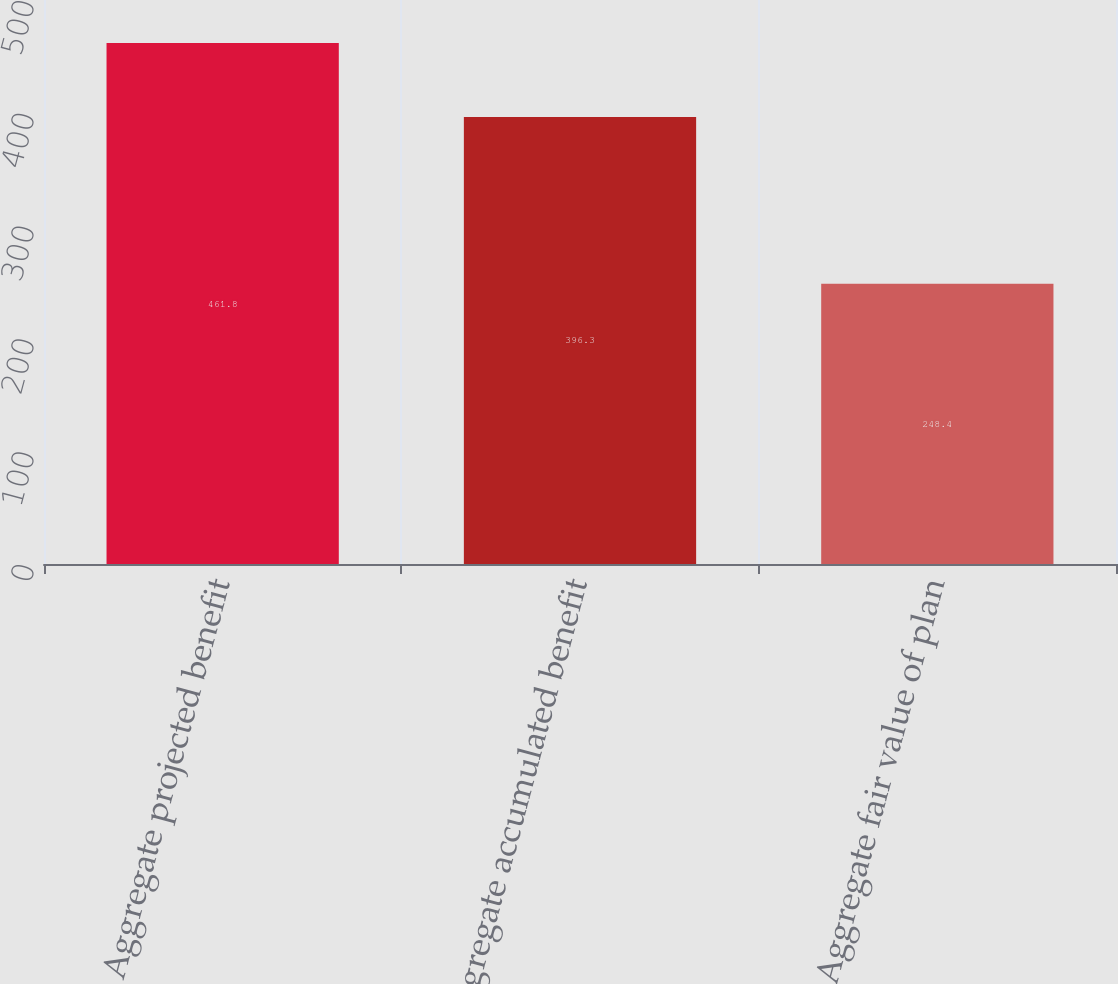Convert chart to OTSL. <chart><loc_0><loc_0><loc_500><loc_500><bar_chart><fcel>Aggregate projected benefit<fcel>Aggregate accumulated benefit<fcel>Aggregate fair value of plan<nl><fcel>461.8<fcel>396.3<fcel>248.4<nl></chart> 